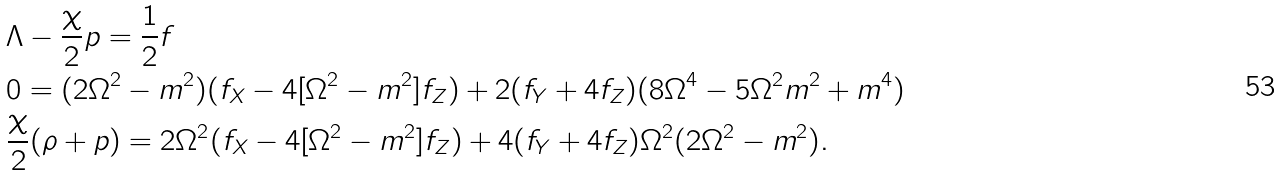Convert formula to latex. <formula><loc_0><loc_0><loc_500><loc_500>& \Lambda - \frac { \chi } { 2 } p = \frac { 1 } { 2 } f \\ & 0 = ( 2 \Omega ^ { 2 } - m ^ { 2 } ) ( f _ { X } - 4 [ \Omega ^ { 2 } - m ^ { 2 } ] f _ { Z } ) + 2 ( f _ { Y } + 4 f _ { Z } ) ( 8 \Omega ^ { 4 } - 5 \Omega ^ { 2 } m ^ { 2 } + m ^ { 4 } ) \\ & \frac { \chi } { 2 } ( \rho + p ) = 2 \Omega ^ { 2 } ( f _ { X } - 4 [ \Omega ^ { 2 } - m ^ { 2 } ] f _ { Z } ) + 4 ( f _ { Y } + 4 f _ { Z } ) \Omega ^ { 2 } ( 2 \Omega ^ { 2 } - m ^ { 2 } ) .</formula> 